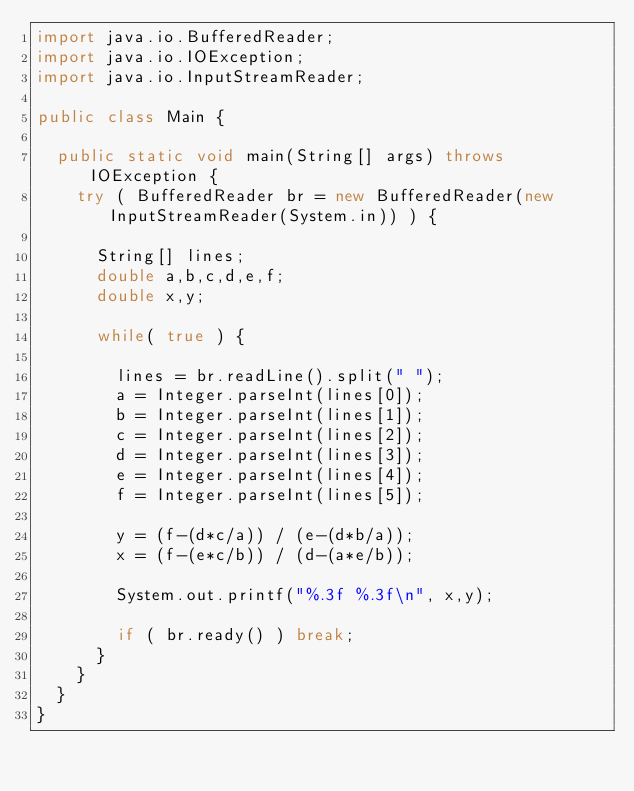<code> <loc_0><loc_0><loc_500><loc_500><_Java_>import java.io.BufferedReader;
import java.io.IOException;
import java.io.InputStreamReader;
 
public class Main {

  public static void main(String[] args) throws IOException {
    try ( BufferedReader br = new BufferedReader(new InputStreamReader(System.in)) ) {

      String[] lines;
      double a,b,c,d,e,f;
      double x,y;

      while( true ) {

        lines = br.readLine().split(" ");
        a = Integer.parseInt(lines[0]);
        b = Integer.parseInt(lines[1]);
        c = Integer.parseInt(lines[2]);
        d = Integer.parseInt(lines[3]);
        e = Integer.parseInt(lines[4]);
        f = Integer.parseInt(lines[5]);

        y = (f-(d*c/a)) / (e-(d*b/a));
        x = (f-(e*c/b)) / (d-(a*e/b));

        System.out.printf("%.3f %.3f\n", x,y);

        if ( br.ready() ) break;
      }
    }
  }
}
</code> 